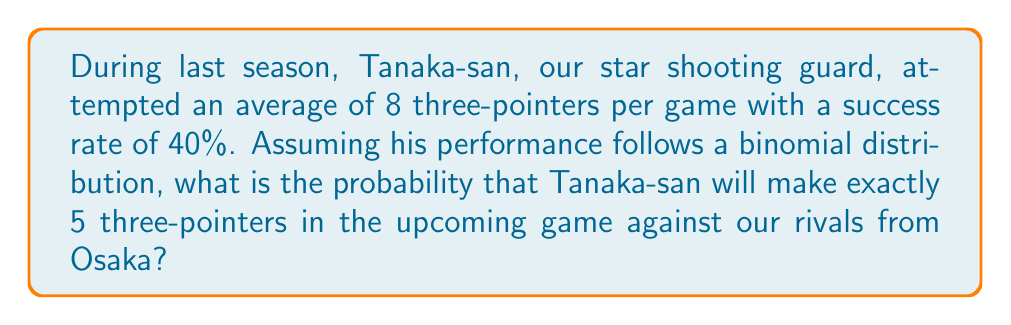Can you answer this question? Let's approach this step-by-step using the binomial probability formula:

1) We're dealing with a binomial distribution because:
   - There's a fixed number of independent trials (8 attempts)
   - Each trial has two possible outcomes (success or failure)
   - The probability of success remains constant (40% or 0.4)

2) The binomial probability formula is:

   $$P(X = k) = \binom{n}{k} p^k (1-p)^{n-k}$$

   Where:
   $n$ = number of trials
   $k$ = number of successes
   $p$ = probability of success on each trial

3) In this case:
   $n = 8$ (attempts)
   $k = 5$ (successful three-pointers)
   $p = 0.4$ (40% success rate)

4) Let's calculate the binomial coefficient $\binom{8}{5}$:

   $$\binom{8}{5} = \frac{8!}{5!(8-5)!} = \frac{8!}{5!3!} = 56$$

5) Now, let's plug everything into the formula:

   $$P(X = 5) = 56 \cdot (0.4)^5 \cdot (1-0.4)^{8-5}$$
   $$= 56 \cdot (0.4)^5 \cdot (0.6)^3$$
   $$= 56 \cdot 0.01024 \cdot 0.216$$
   $$= 0.12386304$$

6) Therefore, the probability is approximately 0.1239 or 12.39%.
Answer: 0.1239 